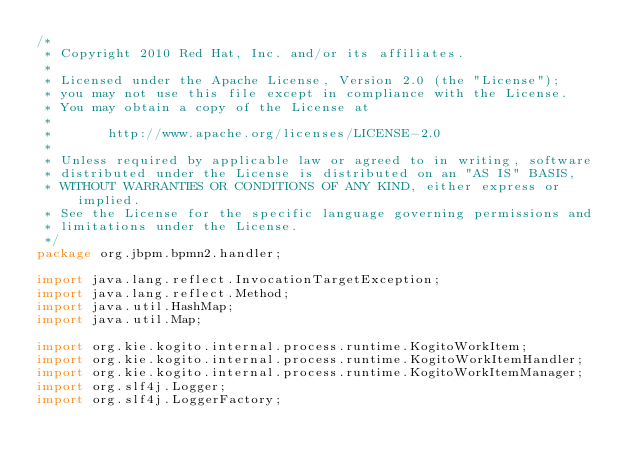<code> <loc_0><loc_0><loc_500><loc_500><_Java_>/*
 * Copyright 2010 Red Hat, Inc. and/or its affiliates.
 *
 * Licensed under the Apache License, Version 2.0 (the "License");
 * you may not use this file except in compliance with the License.
 * You may obtain a copy of the License at
 *
 *       http://www.apache.org/licenses/LICENSE-2.0
 *
 * Unless required by applicable law or agreed to in writing, software
 * distributed under the License is distributed on an "AS IS" BASIS,
 * WITHOUT WARRANTIES OR CONDITIONS OF ANY KIND, either express or implied.
 * See the License for the specific language governing permissions and
 * limitations under the License.
 */
package org.jbpm.bpmn2.handler;

import java.lang.reflect.InvocationTargetException;
import java.lang.reflect.Method;
import java.util.HashMap;
import java.util.Map;

import org.kie.kogito.internal.process.runtime.KogitoWorkItem;
import org.kie.kogito.internal.process.runtime.KogitoWorkItemHandler;
import org.kie.kogito.internal.process.runtime.KogitoWorkItemManager;
import org.slf4j.Logger;
import org.slf4j.LoggerFactory;
</code> 